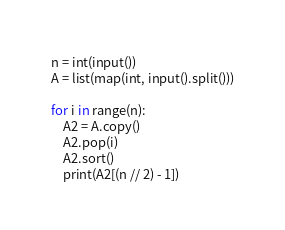<code> <loc_0><loc_0><loc_500><loc_500><_Python_>n = int(input())
A = list(map(int, input().split()))

for i in range(n):
    A2 = A.copy()
    A2.pop(i)
    A2.sort()
    print(A2[(n // 2) - 1])</code> 